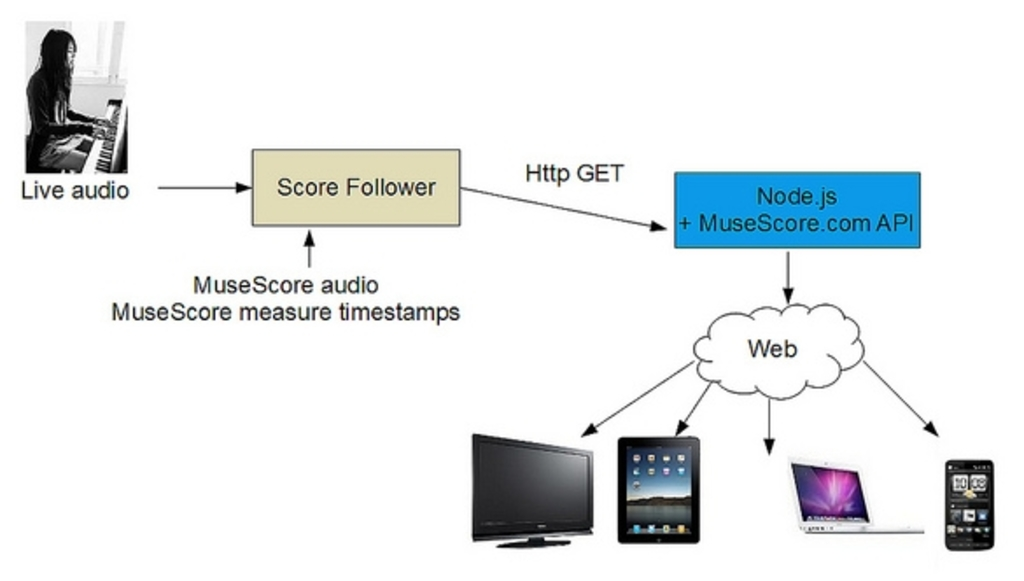Can you explain why Node.js combined with the MuseScore.com API is used in this process and its benefits? Node.js coupled with the MuseScore.com API is utilized primarily for its efficiency in handling asynchronous events and for its high scalability in web applications. This combination facilitates the process of broadcasting the processed audio to the web, allowing for seamless streaming and distribution across different devices. The use of this technology stack ensures that live audio data can be managed in a non-blocking manner and efficiently distributed, enhancing the accessibility and reliability of sharing musical creations. 